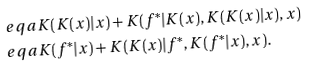<formula> <loc_0><loc_0><loc_500><loc_500>& \ e q a K ( K ( x ) | x ) + K ( f ^ { * } | K ( x ) , K ( K ( x ) | x ) , x ) \\ & \ e q a K ( f ^ { * } | x ) + K ( K ( x ) | f ^ { * } , K ( f ^ { * } | x ) , x ) .</formula> 